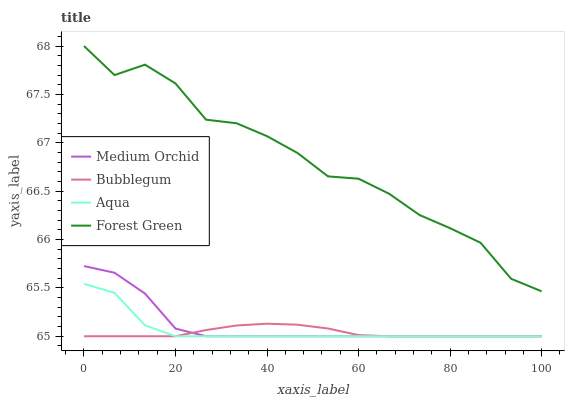Does Medium Orchid have the minimum area under the curve?
Answer yes or no. No. Does Medium Orchid have the maximum area under the curve?
Answer yes or no. No. Is Medium Orchid the smoothest?
Answer yes or no. No. Is Medium Orchid the roughest?
Answer yes or no. No. Does Medium Orchid have the highest value?
Answer yes or no. No. Is Bubblegum less than Forest Green?
Answer yes or no. Yes. Is Forest Green greater than Medium Orchid?
Answer yes or no. Yes. Does Bubblegum intersect Forest Green?
Answer yes or no. No. 